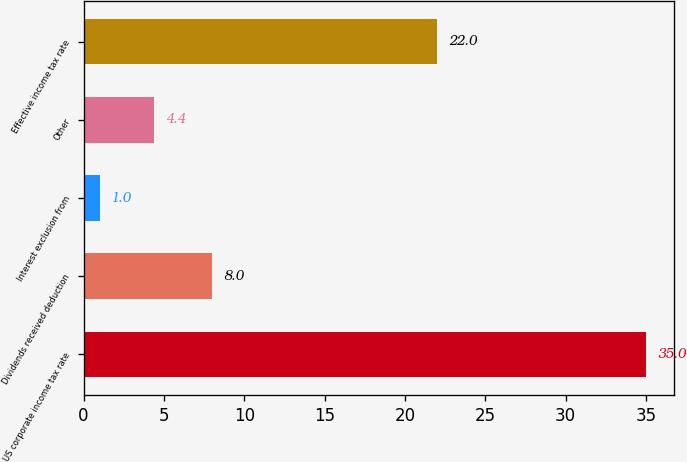Convert chart. <chart><loc_0><loc_0><loc_500><loc_500><bar_chart><fcel>US corporate income tax rate<fcel>Dividends received deduction<fcel>Interest exclusion from<fcel>Other<fcel>Effective income tax rate<nl><fcel>35<fcel>8<fcel>1<fcel>4.4<fcel>22<nl></chart> 